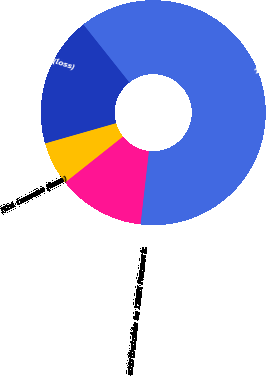<chart> <loc_0><loc_0><loc_500><loc_500><pie_chart><fcel>Total revenue<fcel>Operating income (loss)<fcel>Net income (loss)<fcel>Net income (loss) attributable<fcel>attributable to DISH Network<nl><fcel>62.5%<fcel>18.75%<fcel>6.25%<fcel>12.5%<fcel>0.0%<nl></chart> 